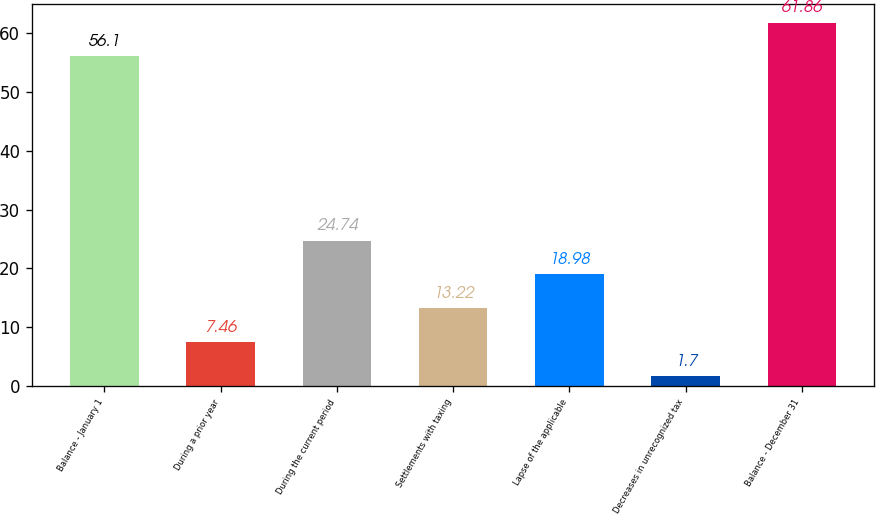Convert chart to OTSL. <chart><loc_0><loc_0><loc_500><loc_500><bar_chart><fcel>Balance - January 1<fcel>During a prior year<fcel>During the current period<fcel>Settlements with taxing<fcel>Lapse of the applicable<fcel>Decreases in unrecognized tax<fcel>Balance - December 31<nl><fcel>56.1<fcel>7.46<fcel>24.74<fcel>13.22<fcel>18.98<fcel>1.7<fcel>61.86<nl></chart> 